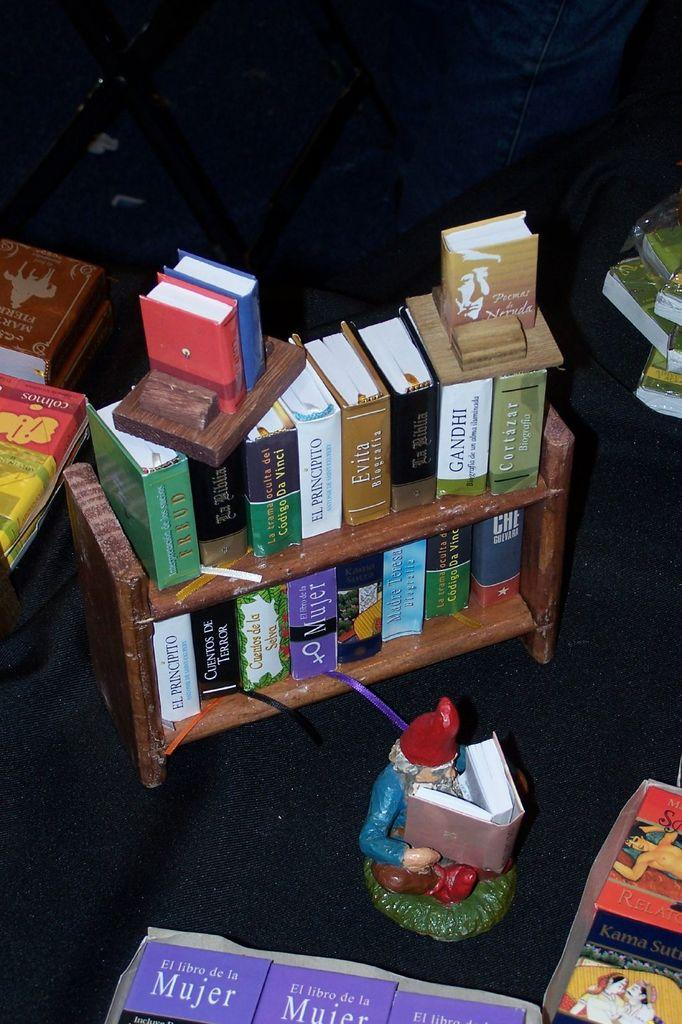<image>
Describe the image concisely. the word Mujer is on the purple book 